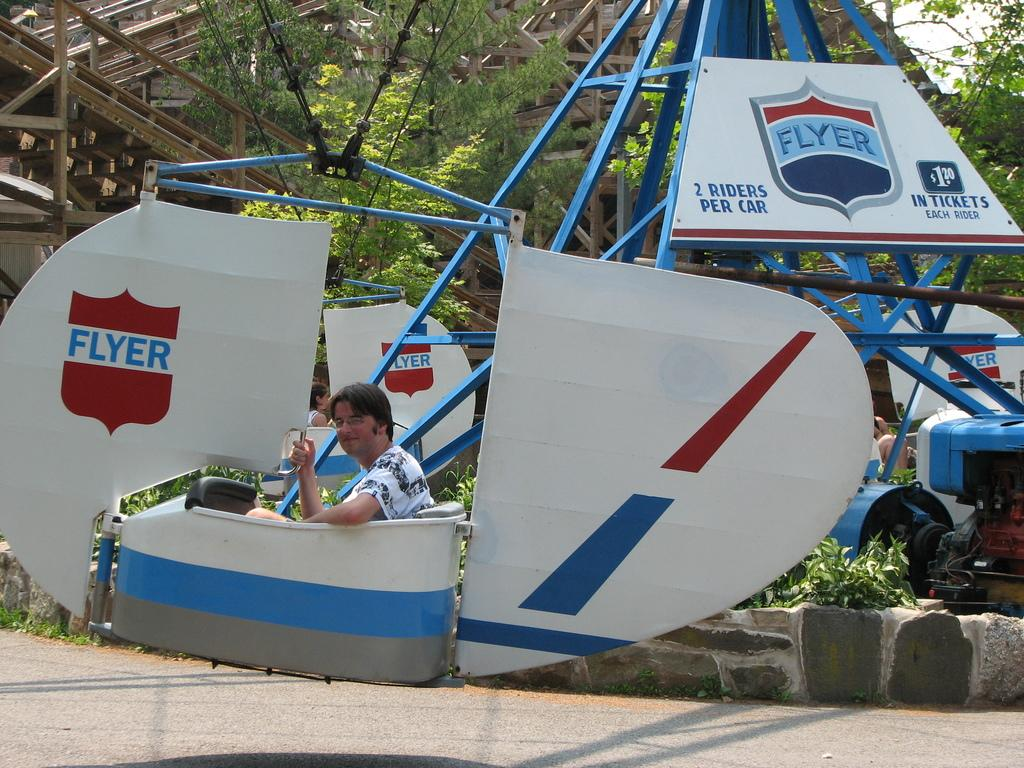<image>
Create a compact narrative representing the image presented. Man sitting inside of a ride that is called FLYER. 